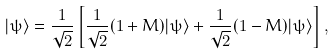<formula> <loc_0><loc_0><loc_500><loc_500>| \psi \rangle = \frac { 1 } { \sqrt { 2 } } \left [ \frac { 1 } { \sqrt { 2 } } ( 1 + M ) | \psi \rangle + \frac { 1 } { \sqrt { 2 } } ( 1 - M ) | \psi \rangle \right ] ,</formula> 